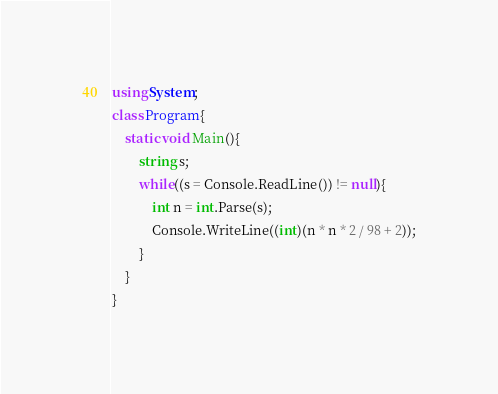<code> <loc_0><loc_0><loc_500><loc_500><_C#_>using System;
class Program{
	static void Main(){
		string s;
		while((s = Console.ReadLine()) != null){
			int n = int.Parse(s);
			Console.WriteLine((int)(n * n * 2 / 98 + 2));
		}
	}
}</code> 